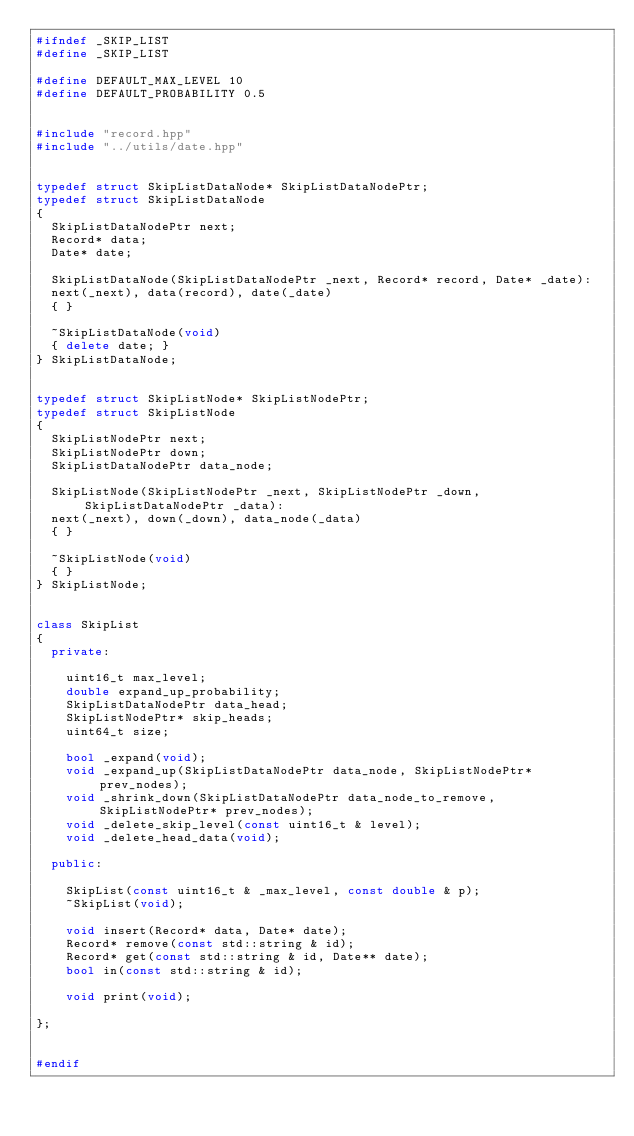<code> <loc_0><loc_0><loc_500><loc_500><_C++_>#ifndef _SKIP_LIST
#define _SKIP_LIST

#define DEFAULT_MAX_LEVEL 10
#define DEFAULT_PROBABILITY 0.5


#include "record.hpp"
#include "../utils/date.hpp"


typedef struct SkipListDataNode* SkipListDataNodePtr;
typedef struct SkipListDataNode
{
  SkipListDataNodePtr next;
  Record* data;
  Date* date;

  SkipListDataNode(SkipListDataNodePtr _next, Record* record, Date* _date):
  next(_next), data(record), date(_date)
  { }

  ~SkipListDataNode(void)
  { delete date; }
} SkipListDataNode;


typedef struct SkipListNode* SkipListNodePtr;
typedef struct SkipListNode
{
  SkipListNodePtr next;
  SkipListNodePtr down;
  SkipListDataNodePtr data_node;

  SkipListNode(SkipListNodePtr _next, SkipListNodePtr _down, SkipListDataNodePtr _data):
  next(_next), down(_down), data_node(_data)
  { }

  ~SkipListNode(void)
  { }
} SkipListNode;


class SkipList
{
  private:

    uint16_t max_level;
    double expand_up_probability;
    SkipListDataNodePtr data_head;
    SkipListNodePtr* skip_heads;
    uint64_t size;

    bool _expand(void);
    void _expand_up(SkipListDataNodePtr data_node, SkipListNodePtr* prev_nodes);
    void _shrink_down(SkipListDataNodePtr data_node_to_remove, SkipListNodePtr* prev_nodes);
    void _delete_skip_level(const uint16_t & level);
    void _delete_head_data(void);

  public:

    SkipList(const uint16_t & _max_level, const double & p);
    ~SkipList(void);

    void insert(Record* data, Date* date);
    Record* remove(const std::string & id);
    Record* get(const std::string & id, Date** date);
    bool in(const std::string & id);

    void print(void);

};


#endif
</code> 